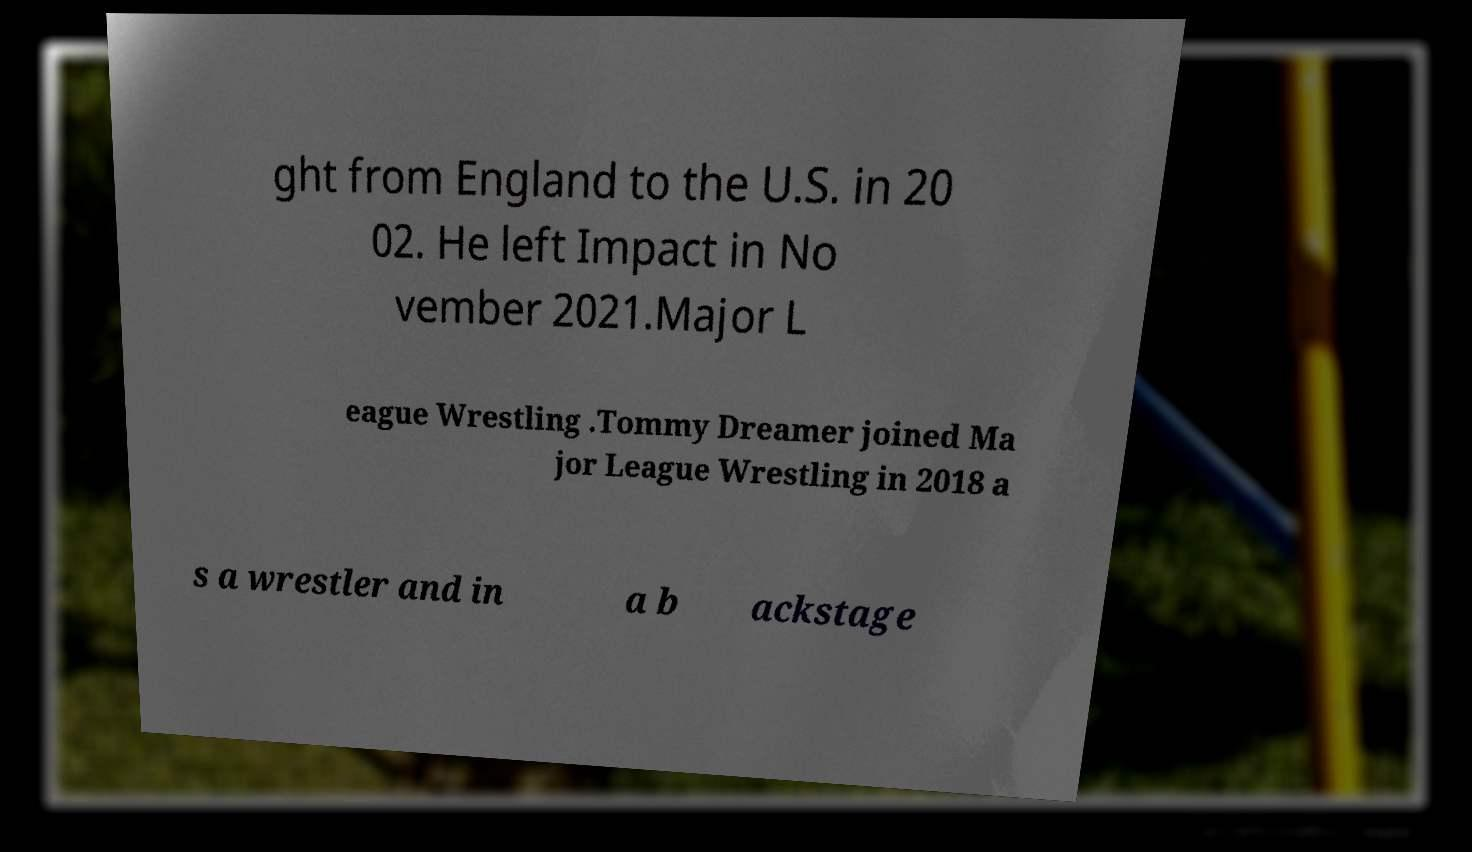For documentation purposes, I need the text within this image transcribed. Could you provide that? ght from England to the U.S. in 20 02. He left Impact in No vember 2021.Major L eague Wrestling .Tommy Dreamer joined Ma jor League Wrestling in 2018 a s a wrestler and in a b ackstage 